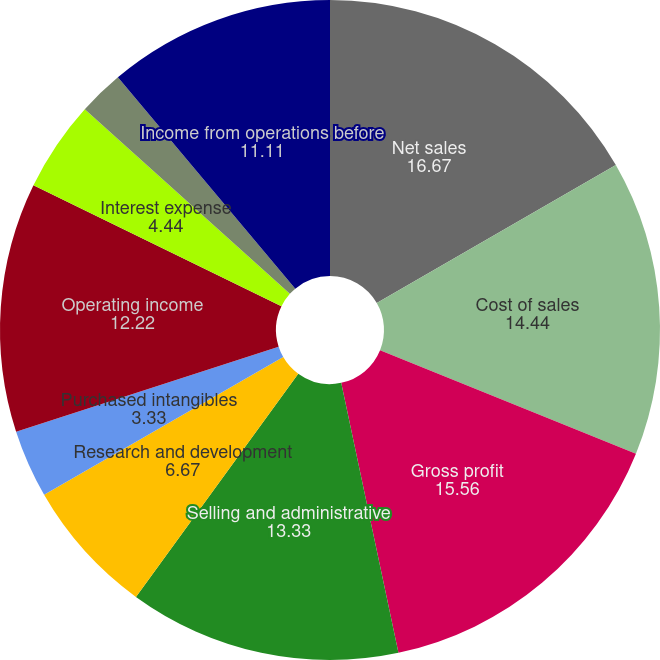<chart> <loc_0><loc_0><loc_500><loc_500><pie_chart><fcel>Net sales<fcel>Cost of sales<fcel>Gross profit<fcel>Selling and administrative<fcel>Research and development<fcel>Purchased intangibles<fcel>Operating income<fcel>Interest expense<fcel>Interest income<fcel>Income from operations before<nl><fcel>16.67%<fcel>14.44%<fcel>15.56%<fcel>13.33%<fcel>6.67%<fcel>3.33%<fcel>12.22%<fcel>4.44%<fcel>2.22%<fcel>11.11%<nl></chart> 